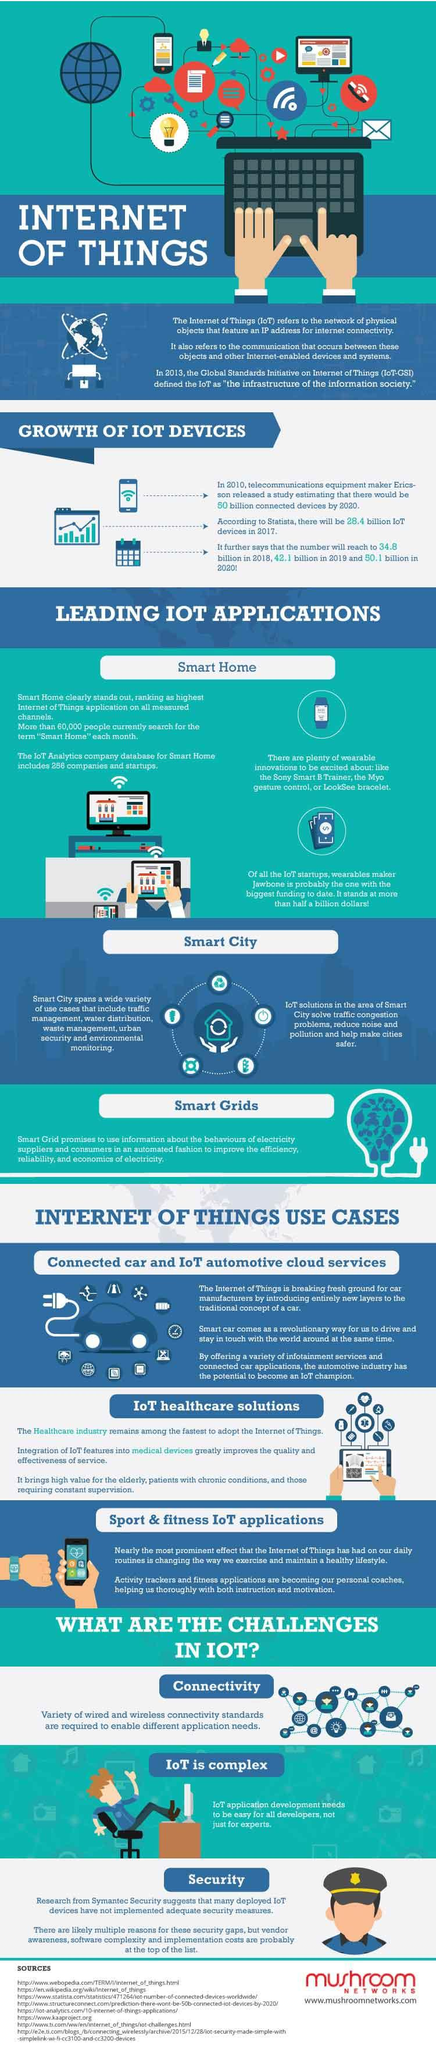Point out several critical features in this image. The number of IoT devices is projected to increase by billions from 2017 to 2018, growing from 6.4 to ... The three main IoT use cases are connected car and IoT automotive cloud services, IoT healthcare solutions, and sport and fitness IoT applications. The expected increase in IoT devices from 2019 to 2020 is projected to be in the billions. The most prominent applications of the Internet of Things (IoT) are Smart Home, Smart City, and Smart Grids, which have become increasingly popular due to their ability to improve efficiency, sustainability, and convenience. The three main challenges in IoT are connectivity, complexity, and security. 